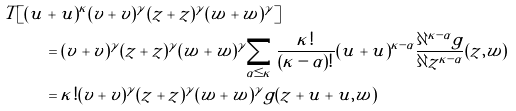<formula> <loc_0><loc_0><loc_500><loc_500>T [ ( u & + \tilde { u } ) ^ { \kappa } ( v + \tilde { v } ) ^ { \gamma } ( z + \tilde { z } ) ^ { \gamma } ( w + \tilde { w } ) ^ { \gamma } ] \\ & = ( v + \tilde { v } ) ^ { \gamma } ( z + \tilde { z } ) ^ { \gamma } ( w + \tilde { w } ) ^ { \gamma } \sum _ { \alpha \leq \kappa } \frac { \kappa ! } { ( \kappa - \alpha ) ! } ( u + \tilde { u } ) ^ { \kappa - \alpha } \frac { \partial ^ { \kappa - \alpha } g } { \partial z ^ { \kappa - \alpha } } ( z , w ) \\ & = \kappa ! ( v + \tilde { v } ) ^ { \gamma } ( z + \tilde { z } ) ^ { \gamma } ( w + \tilde { w } ) ^ { \gamma } g ( z + u + \tilde { u } , w )</formula> 